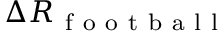<formula> <loc_0><loc_0><loc_500><loc_500>\Delta R _ { f o o t b a l l }</formula> 